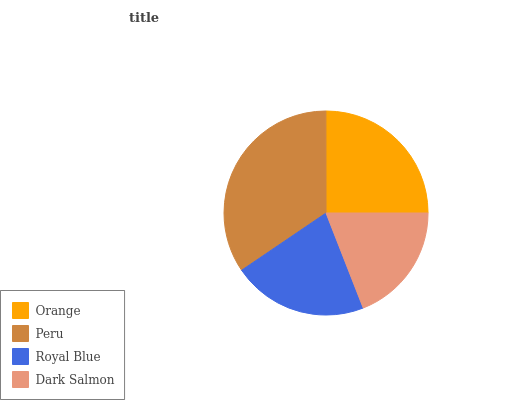Is Dark Salmon the minimum?
Answer yes or no. Yes. Is Peru the maximum?
Answer yes or no. Yes. Is Royal Blue the minimum?
Answer yes or no. No. Is Royal Blue the maximum?
Answer yes or no. No. Is Peru greater than Royal Blue?
Answer yes or no. Yes. Is Royal Blue less than Peru?
Answer yes or no. Yes. Is Royal Blue greater than Peru?
Answer yes or no. No. Is Peru less than Royal Blue?
Answer yes or no. No. Is Orange the high median?
Answer yes or no. Yes. Is Royal Blue the low median?
Answer yes or no. Yes. Is Peru the high median?
Answer yes or no. No. Is Peru the low median?
Answer yes or no. No. 